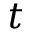Convert formula to latex. <formula><loc_0><loc_0><loc_500><loc_500>t</formula> 